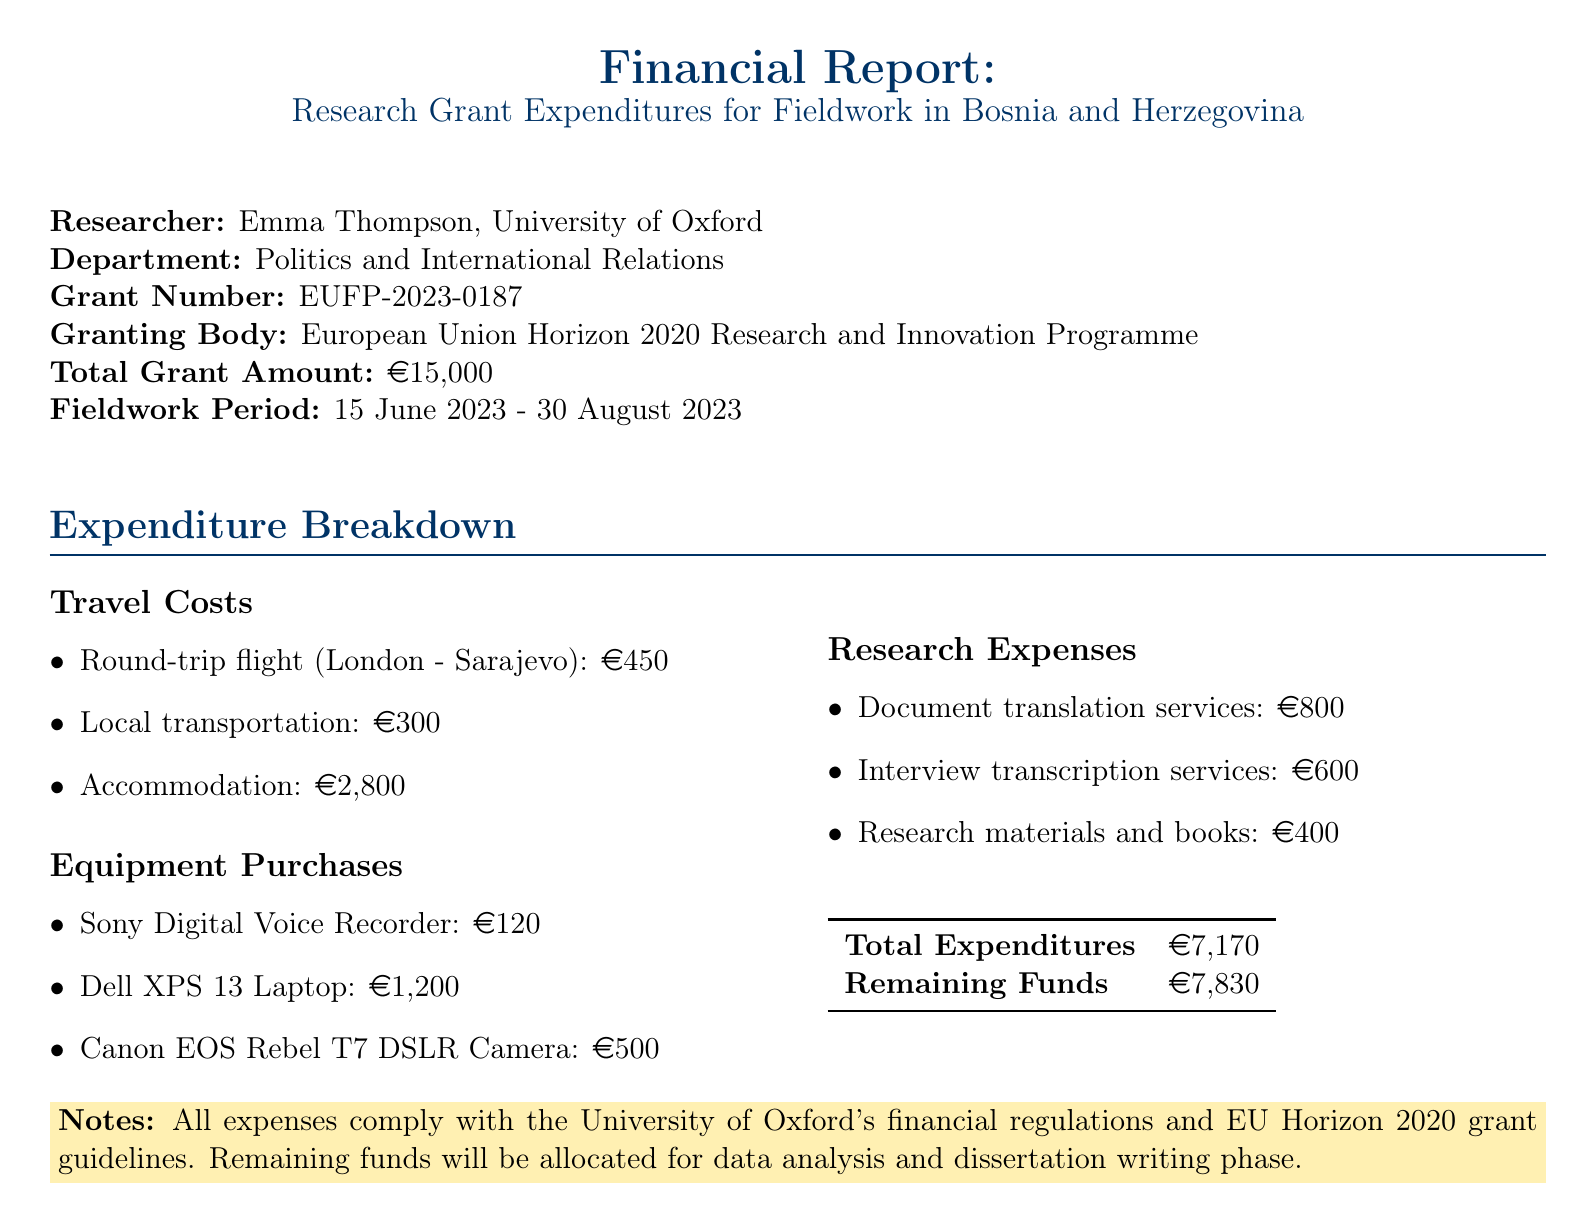What is the total grant amount? The total grant amount is specified in the grant details section of the document.
Answer: €15,000 Who is the researcher? The researcher is listed under the researcher details section, identifying the individual responsible for the report.
Answer: Emma Thompson What is the amount spent on accommodation? The accommodation expense is detailed under travel costs, specifying the spent amount clearly.
Answer: €2,800 What are the remaining funds after expenditures? The remaining funds can be found at the end of the expenditure summary section.
Answer: €7,830 What type of equipment was purchased? The equipment purchases section outlines specific items that were bought for the research.
Answer: Sony ICD-UX560 Digital Voice Recorder What was the start date of the fieldwork period? The start date is provided in the fieldwork period section of the document.
Answer: 15 June 2023 How much was spent on research materials and books? The expenditure for research materials and books is broken down in the research expenses section.
Answer: €400 Which granting body funded the research grant? The granting body is mentioned in the grant details section of the document.
Answer: European Union Horizon 2020 Research and Innovation Programme What regulations do the expenses comply with? The compliance with regulations is noted in the notes section at the end of the document.
Answer: University of Oxford's financial regulations 